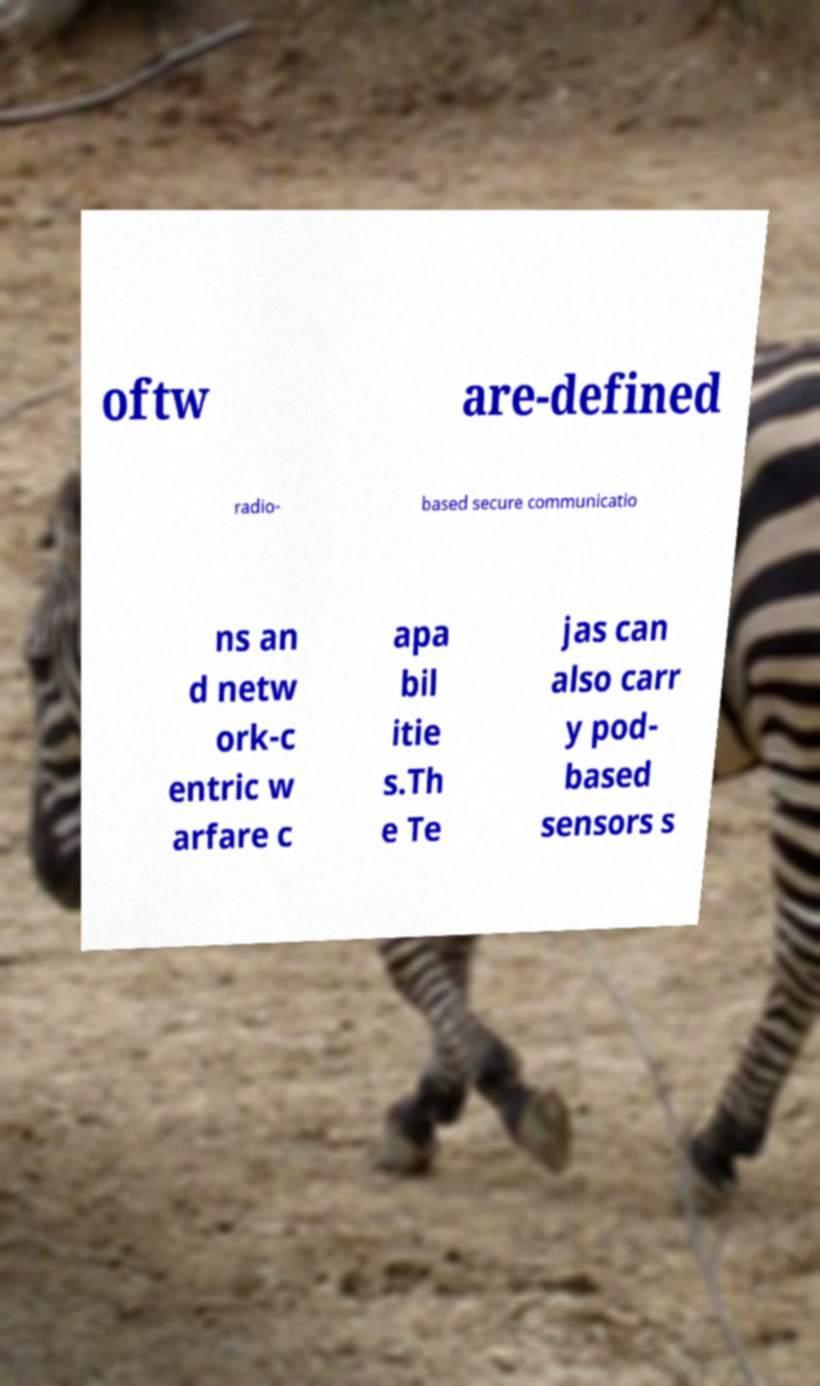Could you extract and type out the text from this image? oftw are-defined radio- based secure communicatio ns an d netw ork-c entric w arfare c apa bil itie s.Th e Te jas can also carr y pod- based sensors s 